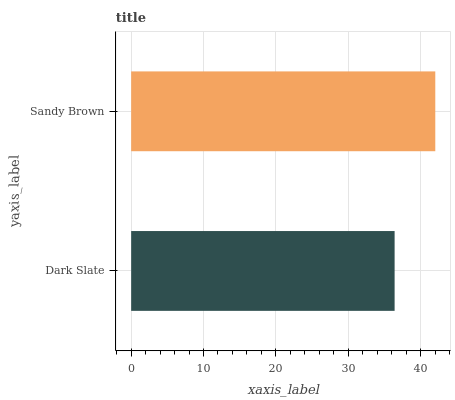Is Dark Slate the minimum?
Answer yes or no. Yes. Is Sandy Brown the maximum?
Answer yes or no. Yes. Is Sandy Brown the minimum?
Answer yes or no. No. Is Sandy Brown greater than Dark Slate?
Answer yes or no. Yes. Is Dark Slate less than Sandy Brown?
Answer yes or no. Yes. Is Dark Slate greater than Sandy Brown?
Answer yes or no. No. Is Sandy Brown less than Dark Slate?
Answer yes or no. No. Is Sandy Brown the high median?
Answer yes or no. Yes. Is Dark Slate the low median?
Answer yes or no. Yes. Is Dark Slate the high median?
Answer yes or no. No. Is Sandy Brown the low median?
Answer yes or no. No. 